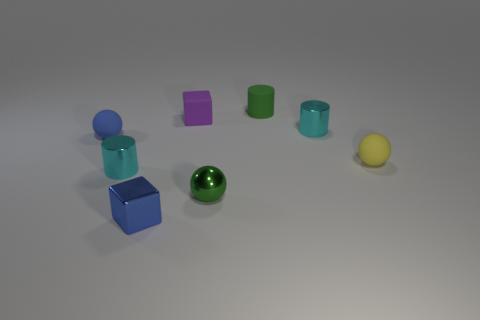Does the tiny matte cylinder have the same color as the tiny shiny sphere?
Make the answer very short. Yes. Does the blue thing that is in front of the blue rubber object have the same shape as the purple thing?
Your answer should be compact. Yes. How many things are cyan metal objects or small spheres to the left of the purple block?
Your answer should be compact. 3. Are there fewer metallic cylinders than green rubber things?
Your response must be concise. No. Is the number of gray rubber balls greater than the number of rubber things?
Your answer should be very brief. No. How many other things are the same material as the tiny blue sphere?
Offer a terse response. 3. What number of metallic spheres are to the left of the tiny cyan metal thing that is to the left of the small blue object in front of the tiny blue rubber sphere?
Keep it short and to the point. 0. How many rubber objects are either purple blocks or green things?
Provide a succinct answer. 2. There is a cylinder behind the purple object; is it the same color as the small ball in front of the tiny yellow rubber sphere?
Your response must be concise. Yes. There is a small rubber thing that is on the right side of the blue cube and on the left side of the tiny green sphere; what color is it?
Give a very brief answer. Purple. 